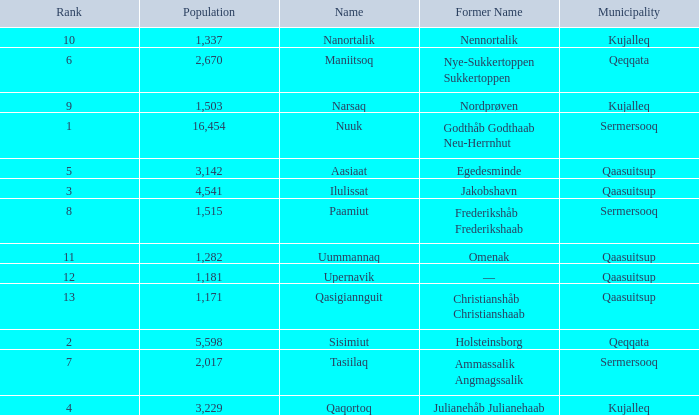What is the population for Rank 11? 1282.0. 